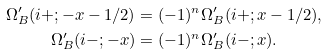Convert formula to latex. <formula><loc_0><loc_0><loc_500><loc_500>\Omega ^ { \prime } _ { B } ( i + ; - x - 1 / 2 ) & = ( - 1 ) ^ { n } \Omega ^ { \prime } _ { B } ( i + ; x - 1 / 2 ) , \\ \Omega ^ { \prime } _ { B } ( i - ; - x ) & = ( - 1 ) ^ { n } \Omega ^ { \prime } _ { B } ( i - ; x ) .</formula> 